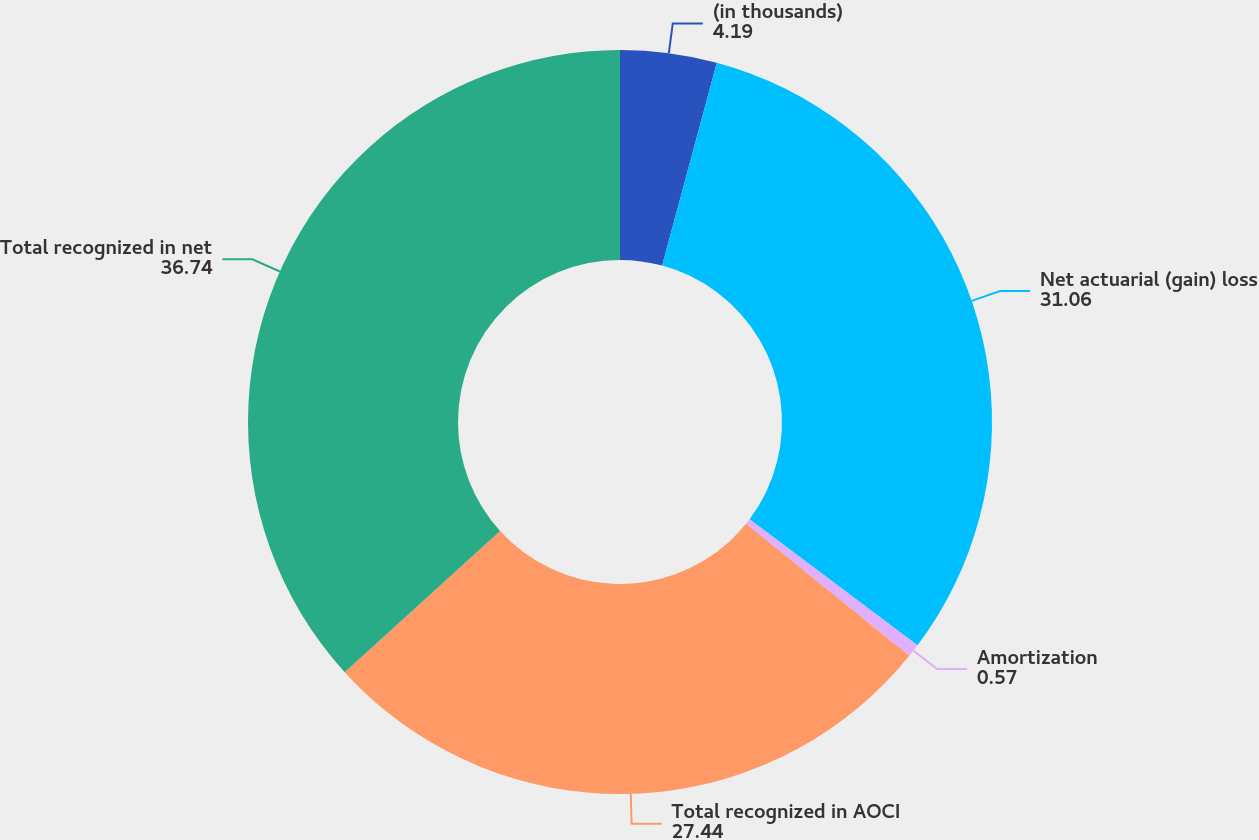Convert chart to OTSL. <chart><loc_0><loc_0><loc_500><loc_500><pie_chart><fcel>(in thousands)<fcel>Net actuarial (gain) loss<fcel>Amortization<fcel>Total recognized in AOCI<fcel>Total recognized in net<nl><fcel>4.19%<fcel>31.06%<fcel>0.57%<fcel>27.44%<fcel>36.74%<nl></chart> 